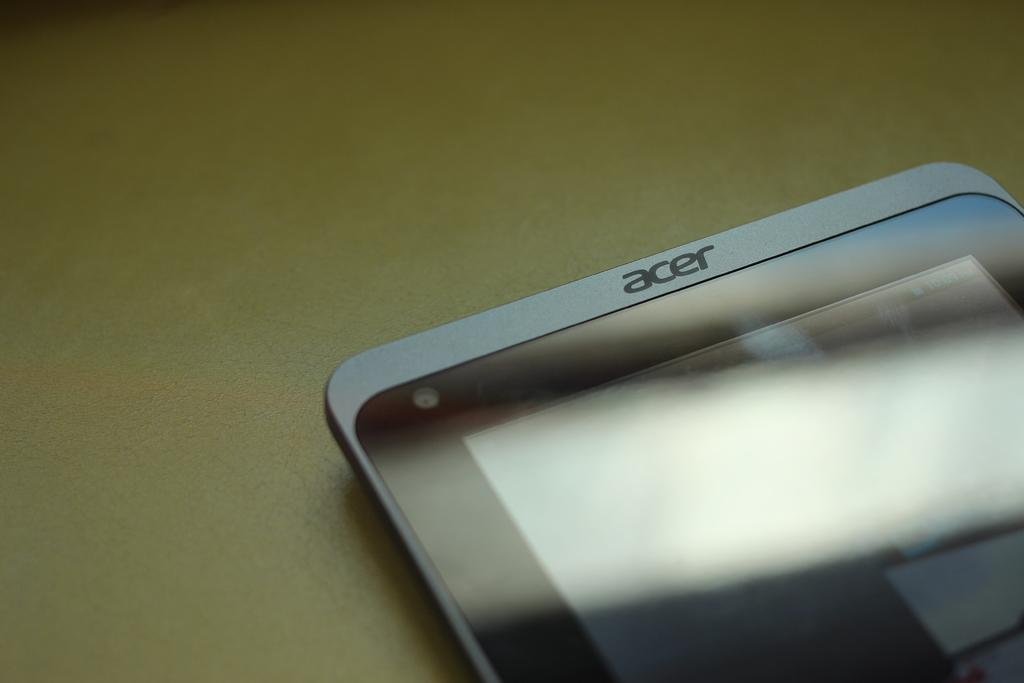<image>
Share a concise interpretation of the image provided. a white and black phone that has the word 'acer' at the top of it 